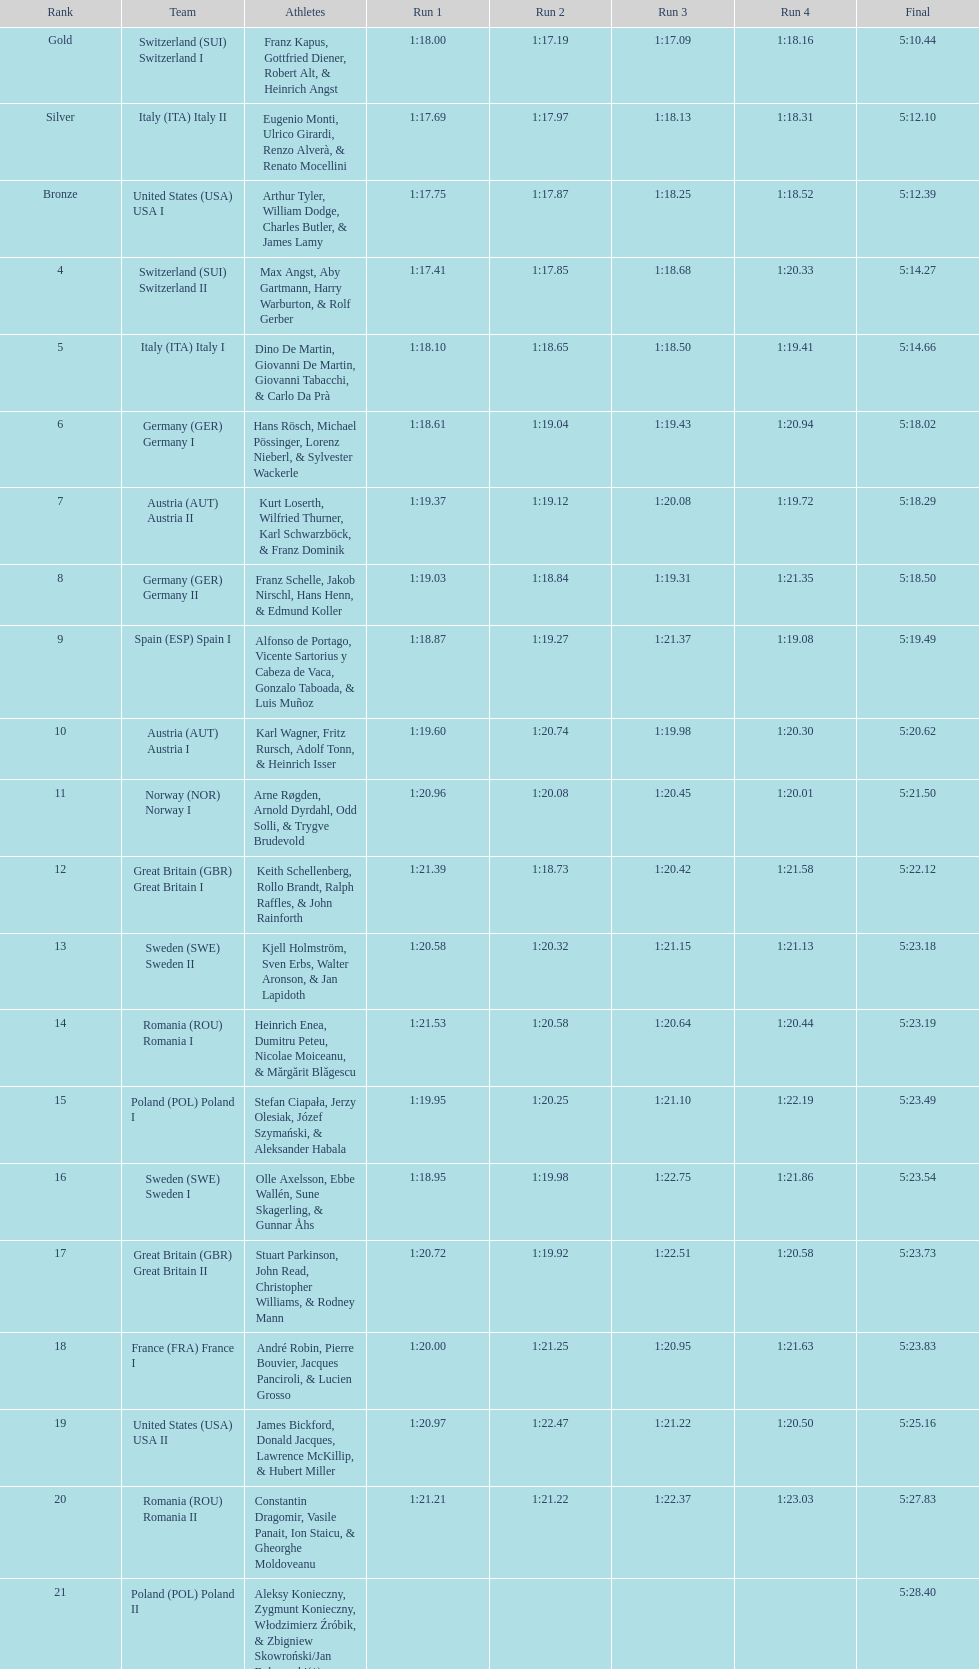Which team won the most runs? Switzerland. 